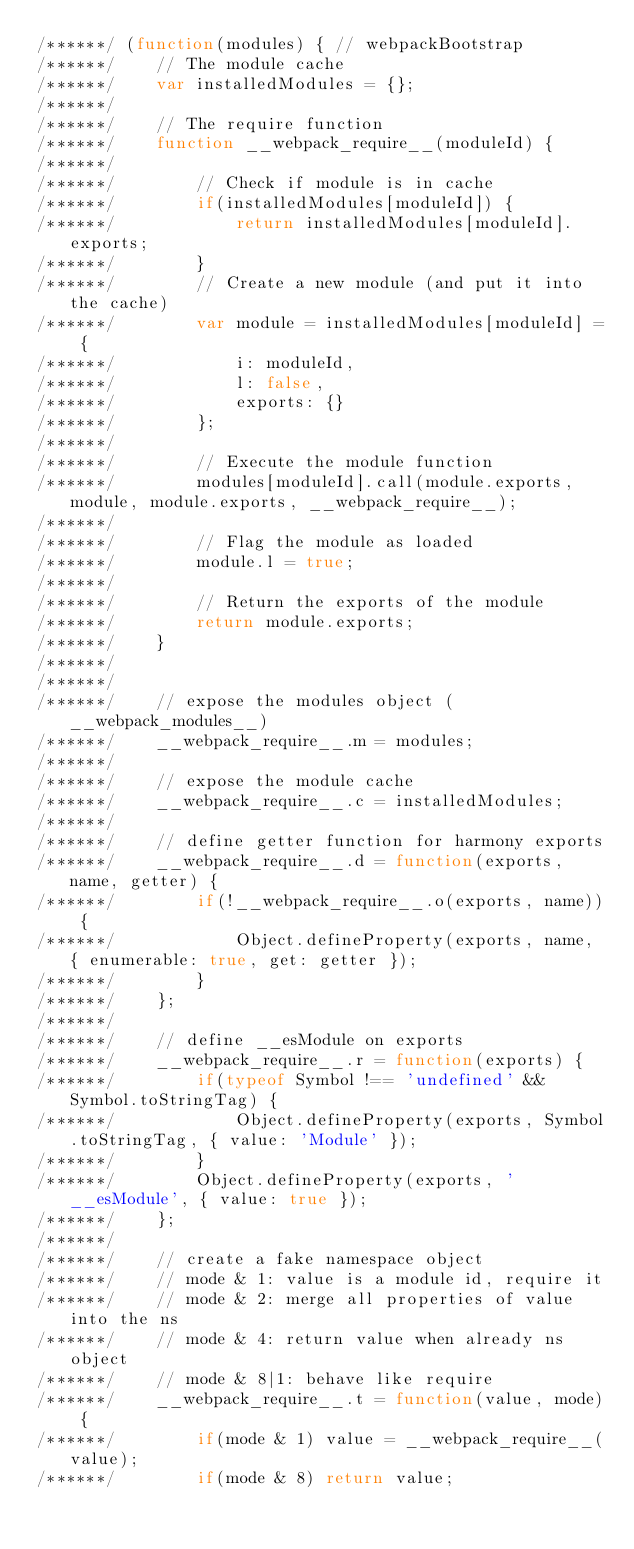Convert code to text. <code><loc_0><loc_0><loc_500><loc_500><_JavaScript_>/******/ (function(modules) { // webpackBootstrap
/******/ 	// The module cache
/******/ 	var installedModules = {};
/******/
/******/ 	// The require function
/******/ 	function __webpack_require__(moduleId) {
/******/
/******/ 		// Check if module is in cache
/******/ 		if(installedModules[moduleId]) {
/******/ 			return installedModules[moduleId].exports;
/******/ 		}
/******/ 		// Create a new module (and put it into the cache)
/******/ 		var module = installedModules[moduleId] = {
/******/ 			i: moduleId,
/******/ 			l: false,
/******/ 			exports: {}
/******/ 		};
/******/
/******/ 		// Execute the module function
/******/ 		modules[moduleId].call(module.exports, module, module.exports, __webpack_require__);
/******/
/******/ 		// Flag the module as loaded
/******/ 		module.l = true;
/******/
/******/ 		// Return the exports of the module
/******/ 		return module.exports;
/******/ 	}
/******/
/******/
/******/ 	// expose the modules object (__webpack_modules__)
/******/ 	__webpack_require__.m = modules;
/******/
/******/ 	// expose the module cache
/******/ 	__webpack_require__.c = installedModules;
/******/
/******/ 	// define getter function for harmony exports
/******/ 	__webpack_require__.d = function(exports, name, getter) {
/******/ 		if(!__webpack_require__.o(exports, name)) {
/******/ 			Object.defineProperty(exports, name, { enumerable: true, get: getter });
/******/ 		}
/******/ 	};
/******/
/******/ 	// define __esModule on exports
/******/ 	__webpack_require__.r = function(exports) {
/******/ 		if(typeof Symbol !== 'undefined' && Symbol.toStringTag) {
/******/ 			Object.defineProperty(exports, Symbol.toStringTag, { value: 'Module' });
/******/ 		}
/******/ 		Object.defineProperty(exports, '__esModule', { value: true });
/******/ 	};
/******/
/******/ 	// create a fake namespace object
/******/ 	// mode & 1: value is a module id, require it
/******/ 	// mode & 2: merge all properties of value into the ns
/******/ 	// mode & 4: return value when already ns object
/******/ 	// mode & 8|1: behave like require
/******/ 	__webpack_require__.t = function(value, mode) {
/******/ 		if(mode & 1) value = __webpack_require__(value);
/******/ 		if(mode & 8) return value;</code> 